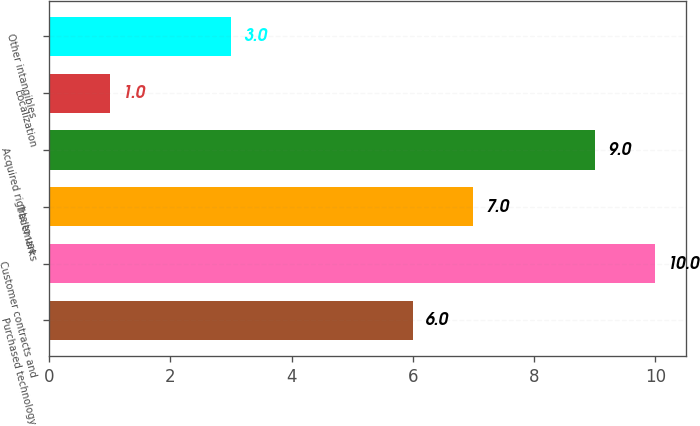Convert chart. <chart><loc_0><loc_0><loc_500><loc_500><bar_chart><fcel>Purchased technology<fcel>Customer contracts and<fcel>Trademarks<fcel>Acquired rights to use<fcel>Localization<fcel>Other intangibles<nl><fcel>6<fcel>10<fcel>7<fcel>9<fcel>1<fcel>3<nl></chart> 